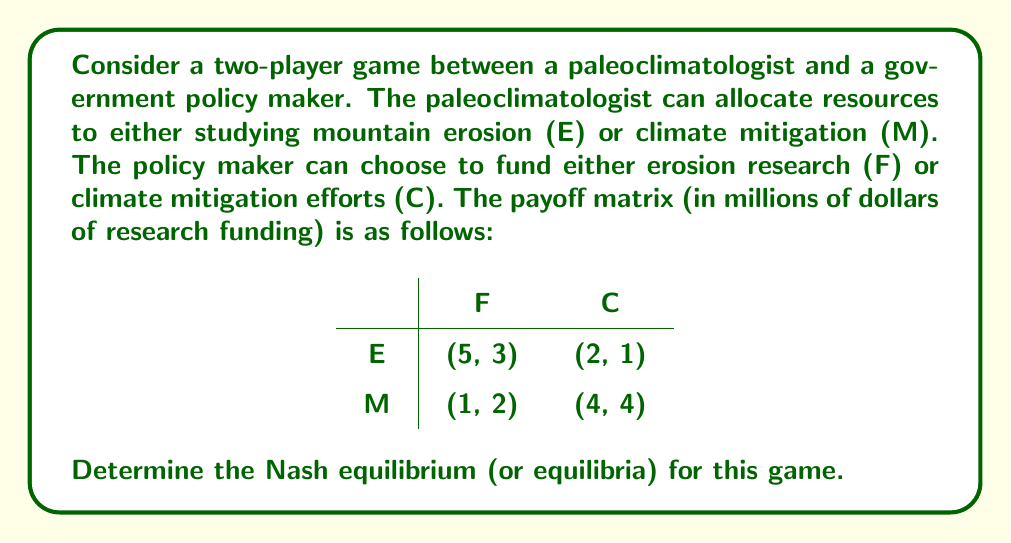Show me your answer to this math problem. To find the Nash equilibrium, we need to determine the best responses for each player given the other player's strategy.

1. For the paleoclimatologist:
   - If policy maker chooses F:
     E gives 5, M gives 1. Best response: E
   - If policy maker chooses C:
     E gives 2, M gives 4. Best response: M

2. For the policy maker:
   - If paleoclimatologist chooses E:
     F gives 3, C gives 1. Best response: F
   - If paleoclimatologist chooses M:
     F gives 2, C gives 4. Best response: C

3. Identify Nash equilibria:
   - (E, F) is a Nash equilibrium because neither player can unilaterally improve their payoff.
   - (M, C) is also a Nash equilibrium for the same reason.

4. Check for mixed strategy equilibrium:
   Let $p$ be the probability of the paleoclimatologist choosing E, and $q$ be the probability of the policy maker choosing F.

   For the paleoclimatologist to be indifferent:
   $$5q + 2(1-q) = 1q + 4(1-q)$$
   $$5q + 2 - 2q = 1q + 4 - 4q$$
   $$3q = 2$$
   $$q = \frac{2}{3}$$

   For the policy maker to be indifferent:
   $$3p + 2(1-p) = 1p + 4(1-p)$$
   $$3p + 2 - 2p = 1p + 4 - 4p$$
   $$p = \frac{2}{3}$$

   The mixed strategy Nash equilibrium exists where both players randomize with probability $\frac{2}{3}$ for their first strategy.

Therefore, this game has three Nash equilibria: two pure strategy equilibria (E, F) and (M, C), and one mixed strategy equilibrium where both players choose their first strategy with probability $\frac{2}{3}$.
Answer: The game has three Nash equilibria:
1. Pure strategy: (E, F)
2. Pure strategy: (M, C)
3. Mixed strategy: Both players choose their first strategy (E for paleoclimatologist, F for policy maker) with probability $\frac{2}{3}$ 